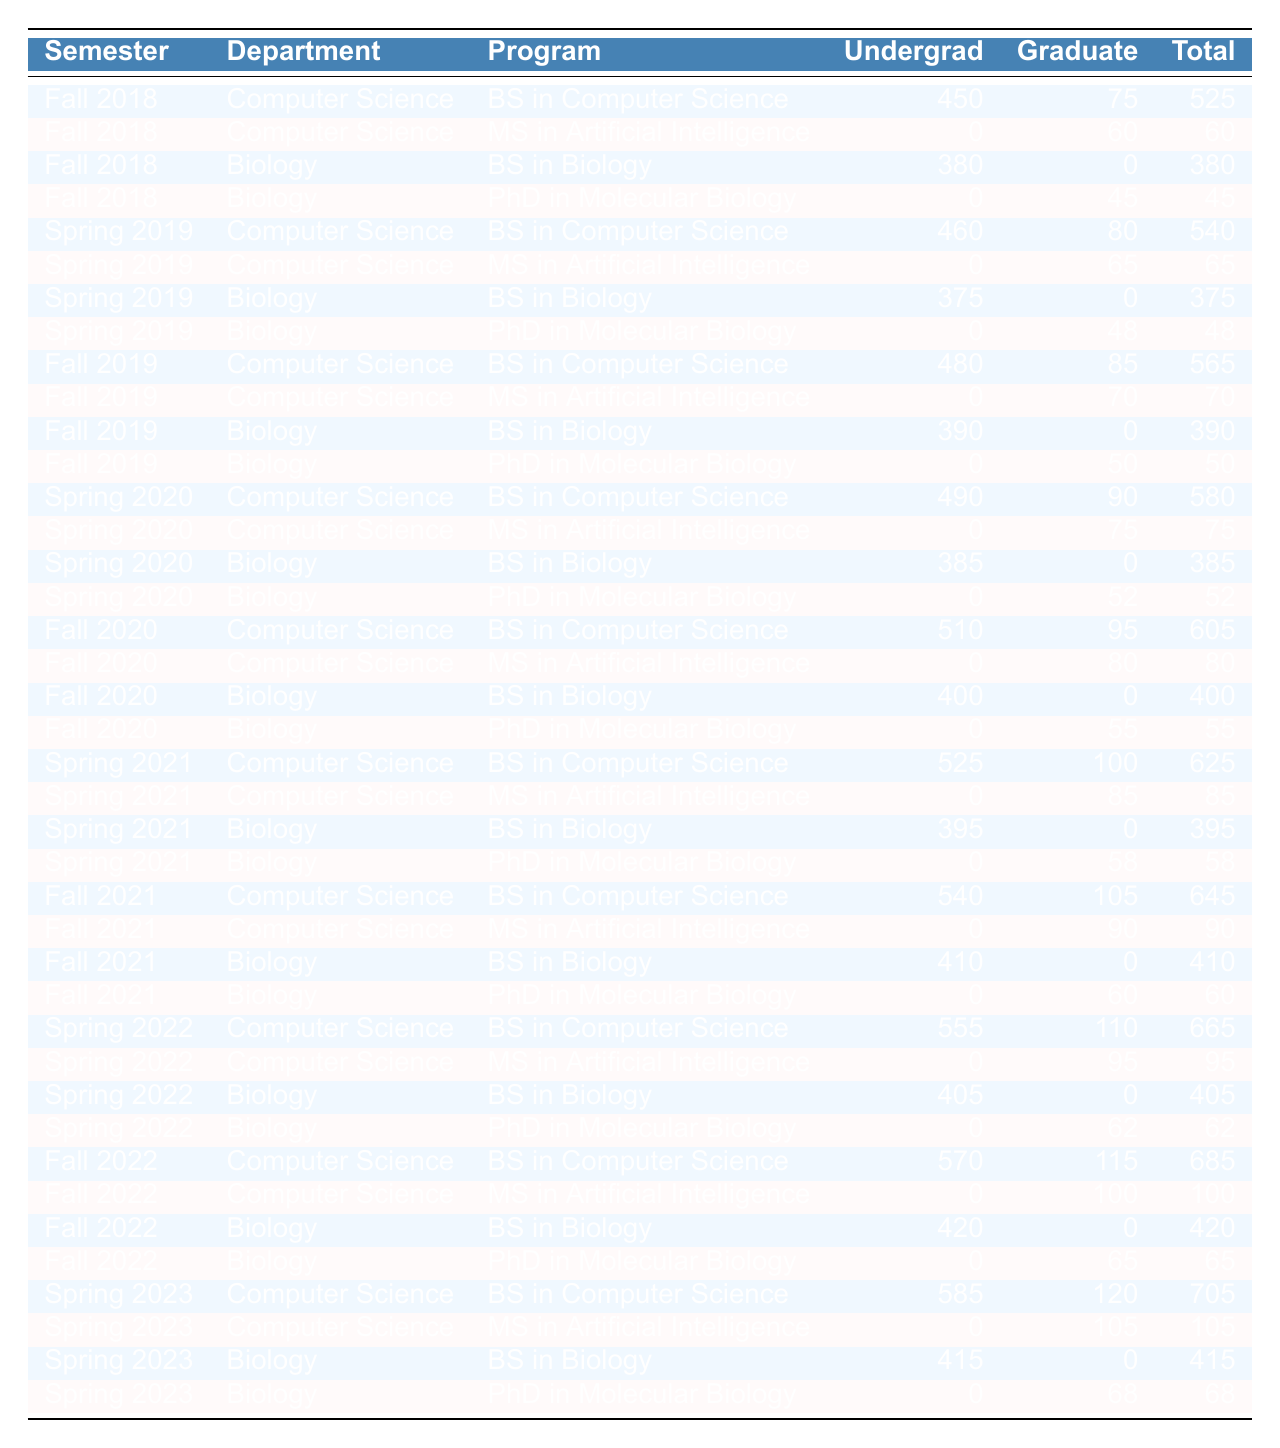What is the total undergraduate enrollment for the Computer Science department in Fall 2021? From the table, I observe that in Fall 2021, the undergraduate enrollment for the Computer Science department (BS in Computer Science) is 540.
Answer: 540 How many total graduates were enrolled in the PhD in Molecular Biology program over all semesters? I check the table for the total graduate enrollment in the PhD in Molecular Biology program across all semesters. Adding up the values: 45 (Fall 2018) + 48 (Spring 2019) + 50 (Fall 2019) + 52 (Spring 2020) + 55 (Fall 2020) + 58 (Spring 2021) + 60 (Fall 2021) + 62 (Spring 2022) + 65 (Fall 2022) + 68 (Spring 2023) results in 60 + 68 + 62 + 60 + 55 + 52 + 50 + 48 + 45 = 548.
Answer: 548 In which semester did the Computer Science program (MS in Artificial Intelligence) have the highest total enrollment? I examine the rows for the MS in Artificial Intelligence program for each semester, noting the total enrollments: 60 (Fall 2018), 65 (Spring 2019), 70 (Fall 2019), 75 (Spring 2020), 80 (Fall 2020), 85 (Spring 2021), 90 (Fall 2021), 95 (Spring 2022), 100 (Fall 2022), and 105 (Spring 2023). The highest total enrollment was in Spring 2023 with 105.
Answer: Spring 2023 What was the average total enrollment for the Biology department across all semesters? To find the average total enrollment for the Biology department, I first list the total enrollment values: 380, 45, 375, 48, 390, 50, 385, 52, 400, 55, 395, 58, 410, 60, 405, 62, 420, 65, 415, 68. Summing these values gives 4398. There are 10 semesters, so the average is 4398 / 20 = 219.9.
Answer: 219.9 Did the undergraduate enrollment in the Computer Science BS program increase every semester? A quick scan through the Computer Science BS program data shows the following undergraduate enrollments over the semesters: 450, 460, 480, 490, 510, 525, 540, 555, 570, 585. Each value increases from the previous semester: thus, there is no decrease.
Answer: Yes What is the difference between the highest and lowest total enrollment in the Computer Science department? By examining the total enrollments, I find 705 (Spring 2023) as the highest and 60 (Fall 2018, MS in AI) as the lowest in total enrollment. The difference between them is 705 - 60 = 645.
Answer: 645 Which program showed the most consistent increase in graduate enrollment over the years? I review the graduate enrollment for all programs and find the MS in Artificial Intelligence enrollment yearly: 60, 65, 70, 75, 80, 85, 90, 95, 100, 105. Every semester shows a clear increase. The PhD in Molecular Biology fluctuated and had some years with no growth. Thus, MS in AI is the most consistent.
Answer: MS in Artificial Intelligence What was the total enrollment for the BS in Biology in Spring 2022? Referring to the table, in Spring 2022, the total enrollment for the BS in Biology is 405.
Answer: 405 In Fall 2020, what percentage of the total enrollment in Biology was constituted by graduate students? The total enrollment for the Biology department in Fall 2020 is 400 (BS) + 55 (PhD) = 455. The graduate enrollment is 55. To find the percentage of graduate students, calculate (55 / 455) * 100 = 12.1%.
Answer: 12.1% What is the trend of total enrollment in undergraduate programs for the Computer Science department over the 10 semesters? Looking at the undergraduate enrollment numbers for the Computer Science department, it shows consistent growth: 450, 460, 480, 490, 510, 525, 540, 555, 570, and 585. This indicates a positive trend in enrollment over the semesters.
Answer: Consistent increase 